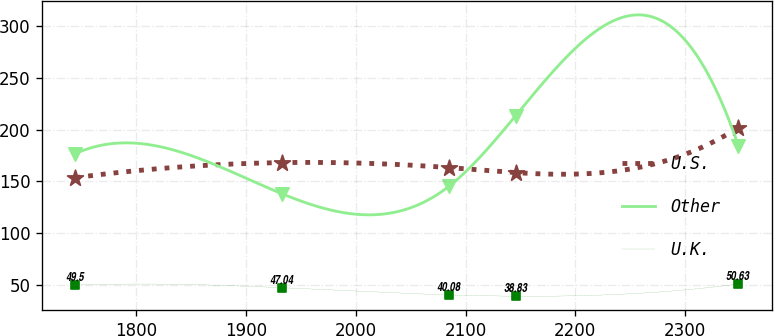Convert chart. <chart><loc_0><loc_0><loc_500><loc_500><line_chart><ecel><fcel>U.S.<fcel>Other<fcel>U.K.<nl><fcel>1744.35<fcel>153.54<fcel>176.82<fcel>49.5<nl><fcel>1932.89<fcel>168.09<fcel>137.87<fcel>47.04<nl><fcel>2085.2<fcel>163.24<fcel>145.42<fcel>40.08<nl><fcel>2145.64<fcel>158.39<fcel>213.4<fcel>38.83<nl><fcel>2348.77<fcel>202.06<fcel>184.37<fcel>50.63<nl></chart> 